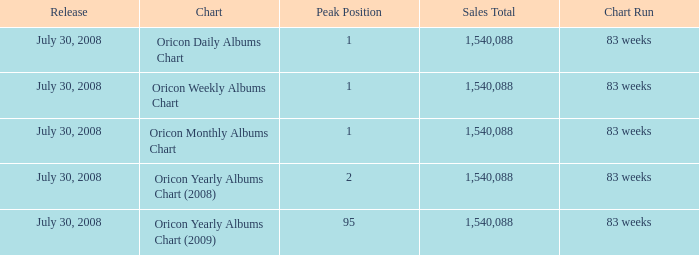What is the total sales figure for a chart of oricon's monthly albums chart? 1540088.0. 